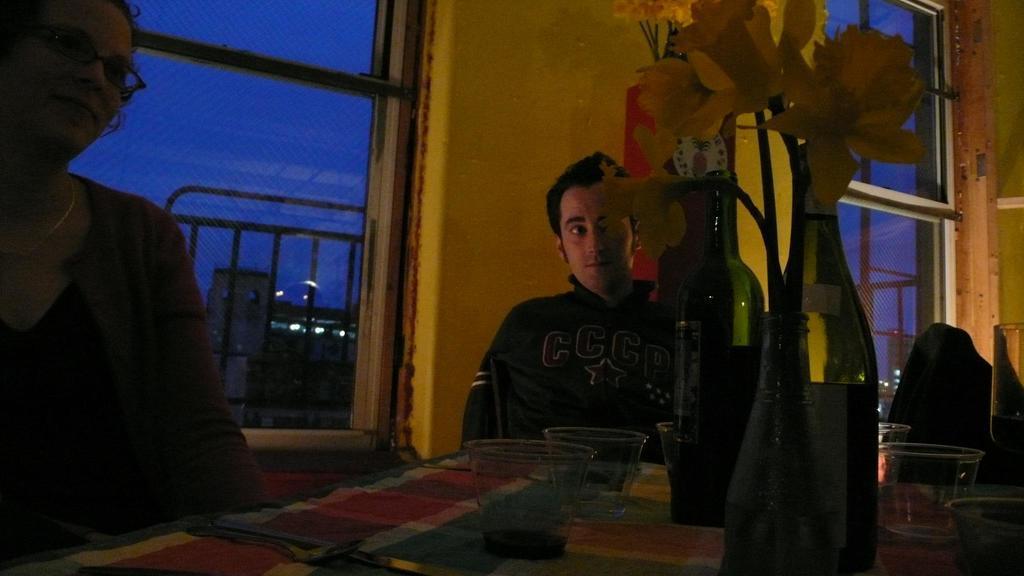Please provide a concise description of this image. There are 2 persons sitting on the chair at the table. On the table we can see spoons,glasses and flower vase. In the background there are windows and a wall. Through window we can see sky,lights and poles. 